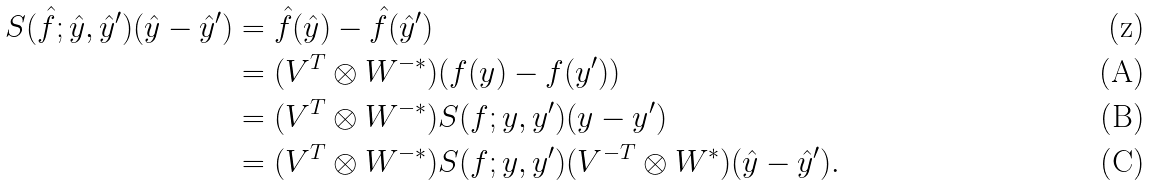Convert formula to latex. <formula><loc_0><loc_0><loc_500><loc_500>S ( \hat { f } ; \hat { y } , \hat { y } ^ { \prime } ) ( \hat { y } - \hat { y } ^ { \prime } ) & = \hat { f } ( \hat { y } ) - \hat { f } ( \hat { y } ^ { \prime } ) \\ & = ( V ^ { T } \otimes W ^ { - * } ) ( f ( y ) - f ( y ^ { \prime } ) ) \\ & = ( V ^ { T } \otimes W ^ { - * } ) S ( f ; y , y ^ { \prime } ) ( y - y ^ { \prime } ) \\ & = ( V ^ { T } \otimes W ^ { - * } ) S ( f ; y , y ^ { \prime } ) ( V ^ { - T } \otimes W ^ { * } ) ( \hat { y } - \hat { y } ^ { \prime } ) .</formula> 